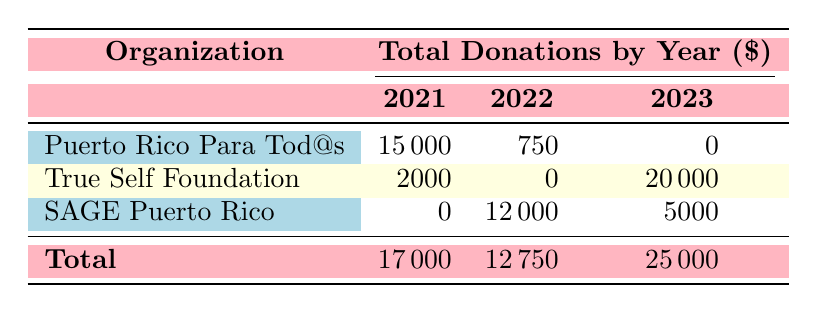What is the highest total donation amount recorded for any organization in a single year? Looking at the table, the highest total donation amount is 20000, which belongs to the True Self Foundation for the year 2023.
Answer: 20000 Which organization received donations in all three years listed? The table shows that only SAGE Puerto Rico received donations in 2022 and 2023, but did not receive any in 2021, hence no organization received donations in all three years.
Answer: No What is the total amount donated to Puerto Rico Para Tod@s across all years? Summing the donations: 15000 (2021) + 750 (2022) + 0 (2023) equals 15750.
Answer: 15750 Which year had the lowest total donations recorded for any organization? In the table, the total donations for 2021 are 17000, for 2022 are 12750, and for 2023 are 25000. Comparing these, 12750 (2022) is the lowest.
Answer: 2022 Did True Self Foundation raise a lower amount in 2021 than in 2023? The total donation amount for True Self Foundation in 2021 is 2000, while in 2023 it is 20000. Since 2000 is less than 20000, the statement is true.
Answer: Yes What is the average donation amount for SAGE Puerto Rico across the years it received donations? SAGE Puerto Rico received 12000 in 2022 and 5000 in 2023. The average is (12000 + 5000) / 2 = 8500.
Answer: 8500 Overall, how much more did True Self Foundation receive than the total donations of Puerto Rico Para Tod@s in the year 2021? True Self Foundation received 2000 in 2021, and Puerto Rico Para Tod@s received 15000. The difference is 20000 (True Self Foundation) - 15000 (Puerto Rico Para Tod@s) = -13000, so True Self Foundation received less.
Answer: No What percentage of total donations from 2023 came from True Self Foundation? Total donations for 2023 are 25000. True Self Foundation's donation is 20000. The percentage is (20000 / 25000) * 100 = 80%.
Answer: 80% 